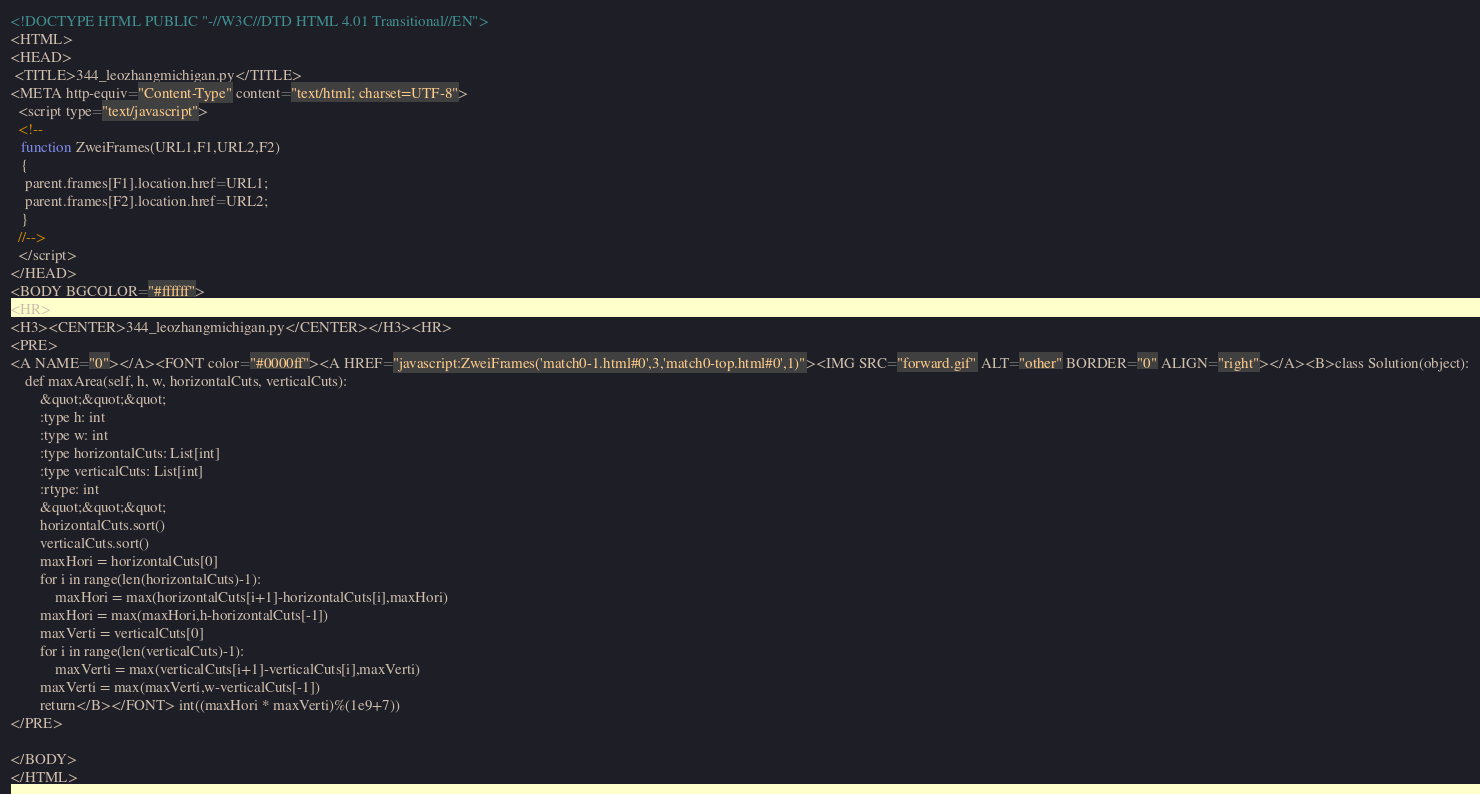<code> <loc_0><loc_0><loc_500><loc_500><_HTML_><!DOCTYPE HTML PUBLIC "-//W3C//DTD HTML 4.01 Transitional//EN">
<HTML>
<HEAD>
 <TITLE>344_leozhangmichigan.py</TITLE>
<META http-equiv="Content-Type" content="text/html; charset=UTF-8">
  <script type="text/javascript">
  <!--
   function ZweiFrames(URL1,F1,URL2,F2)
   {
    parent.frames[F1].location.href=URL1;
    parent.frames[F2].location.href=URL2;
   }
  //-->
  </script>
</HEAD>
<BODY BGCOLOR="#ffffff">
<HR>
<H3><CENTER>344_leozhangmichigan.py</CENTER></H3><HR>
<PRE>
<A NAME="0"></A><FONT color="#0000ff"><A HREF="javascript:ZweiFrames('match0-1.html#0',3,'match0-top.html#0',1)"><IMG SRC="forward.gif" ALT="other" BORDER="0" ALIGN="right"></A><B>class Solution(object):
    def maxArea(self, h, w, horizontalCuts, verticalCuts):
        &quot;&quot;&quot;
        :type h: int
        :type w: int
        :type horizontalCuts: List[int]
        :type verticalCuts: List[int]
        :rtype: int
        &quot;&quot;&quot;
        horizontalCuts.sort()
        verticalCuts.sort()
        maxHori = horizontalCuts[0]
        for i in range(len(horizontalCuts)-1):
            maxHori = max(horizontalCuts[i+1]-horizontalCuts[i],maxHori)
        maxHori = max(maxHori,h-horizontalCuts[-1])
        maxVerti = verticalCuts[0]
        for i in range(len(verticalCuts)-1):
            maxVerti = max(verticalCuts[i+1]-verticalCuts[i],maxVerti)
        maxVerti = max(maxVerti,w-verticalCuts[-1])
        return</B></FONT> int((maxHori * maxVerti)%(1e9+7))
</PRE>

</BODY>
</HTML>
</code> 